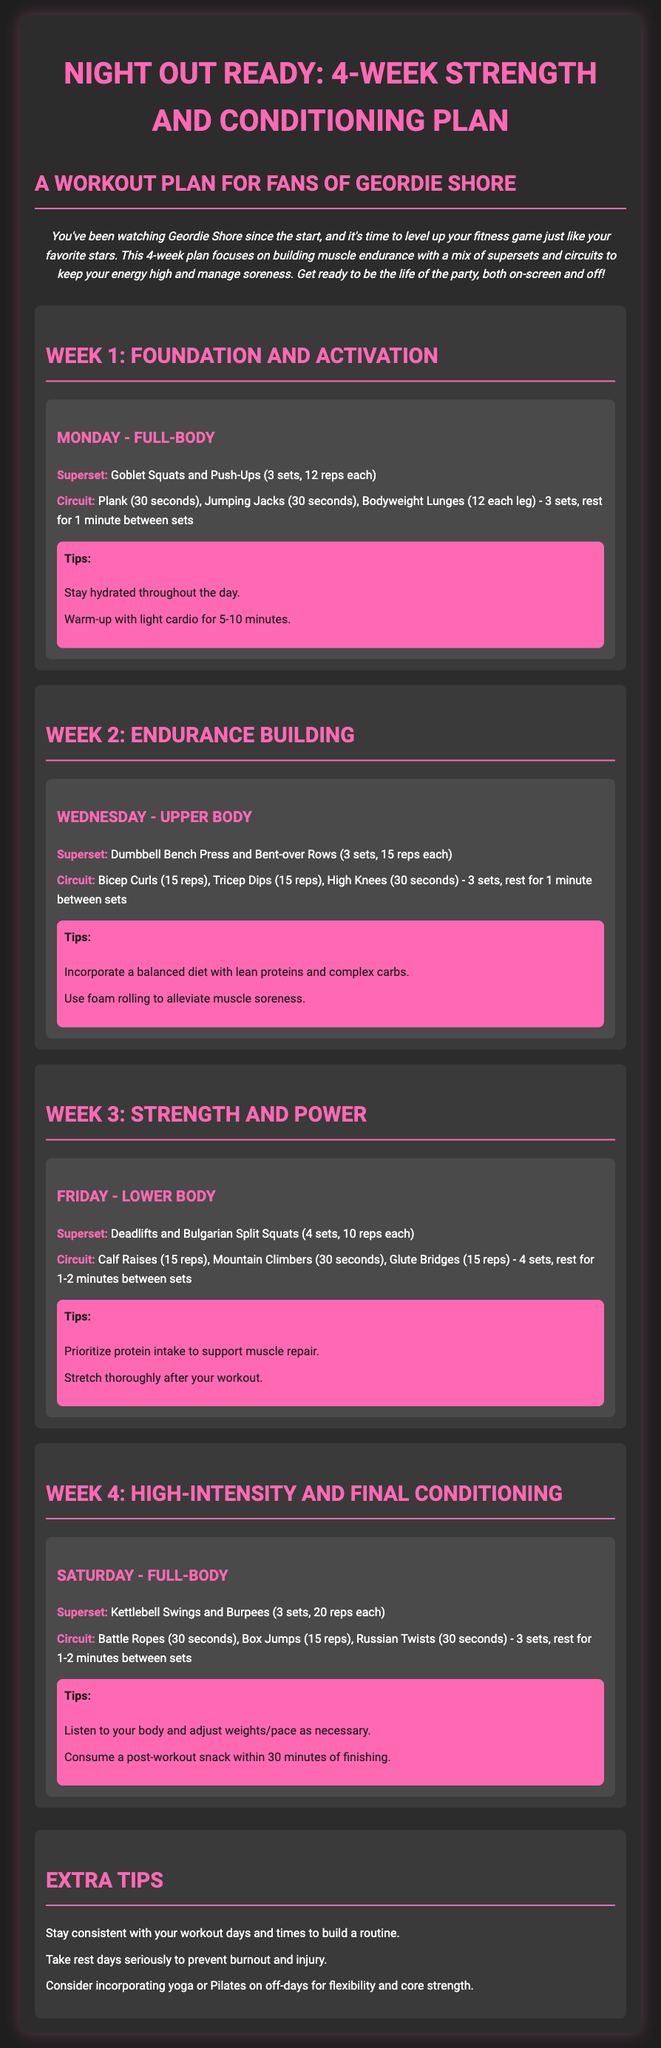What is the title of the workout plan? The title is presented prominently at the top of the document, indicating the overall focus of the plan.
Answer: Night Out Ready: 4-Week Strength and Conditioning Plan How many weeks does the plan cover? The title of the plan specifies the duration it covers as four weeks.
Answer: 4 weeks What is the focus of Week 1 workouts? Each week is introduced with its specific aim or theme, and Week 1 is dedicated to establishing foundational exercises.
Answer: Foundation and Activation What is the recommended rest time between sets in the Week 1 circuit? The document lists the rest period recommended between these sets explicitly for the circuit workouts.
Answer: 1 minute Which day of the week is specifically assigned to the upper body? The document outlines the exercises planned for various days, with a particular workout dedicated to the upper body on Wednesday.
Answer: Wednesday What exercise is included in the Week 3 lower body superset? The document lists exercises included in supersets for each week, highlighting key exercises for the lower body.
Answer: Deadlifts What type of tips are provided at the end of each workout section? Each workout section includes a specific category of advice aimed at enhancing workout effectiveness and recovery.
Answer: Tips How many reps are recommended for the Goblet Squats in Week 1? The document provides explicit details on the number of repetitions for various exercises, including goblet squats.
Answer: 12 reps What is advised to consume within 30 minutes after a workout in Week 4? The tips section refers to a specific type of food intake that should be done post-workout for optimal recovery.
Answer: Post-workout snack 